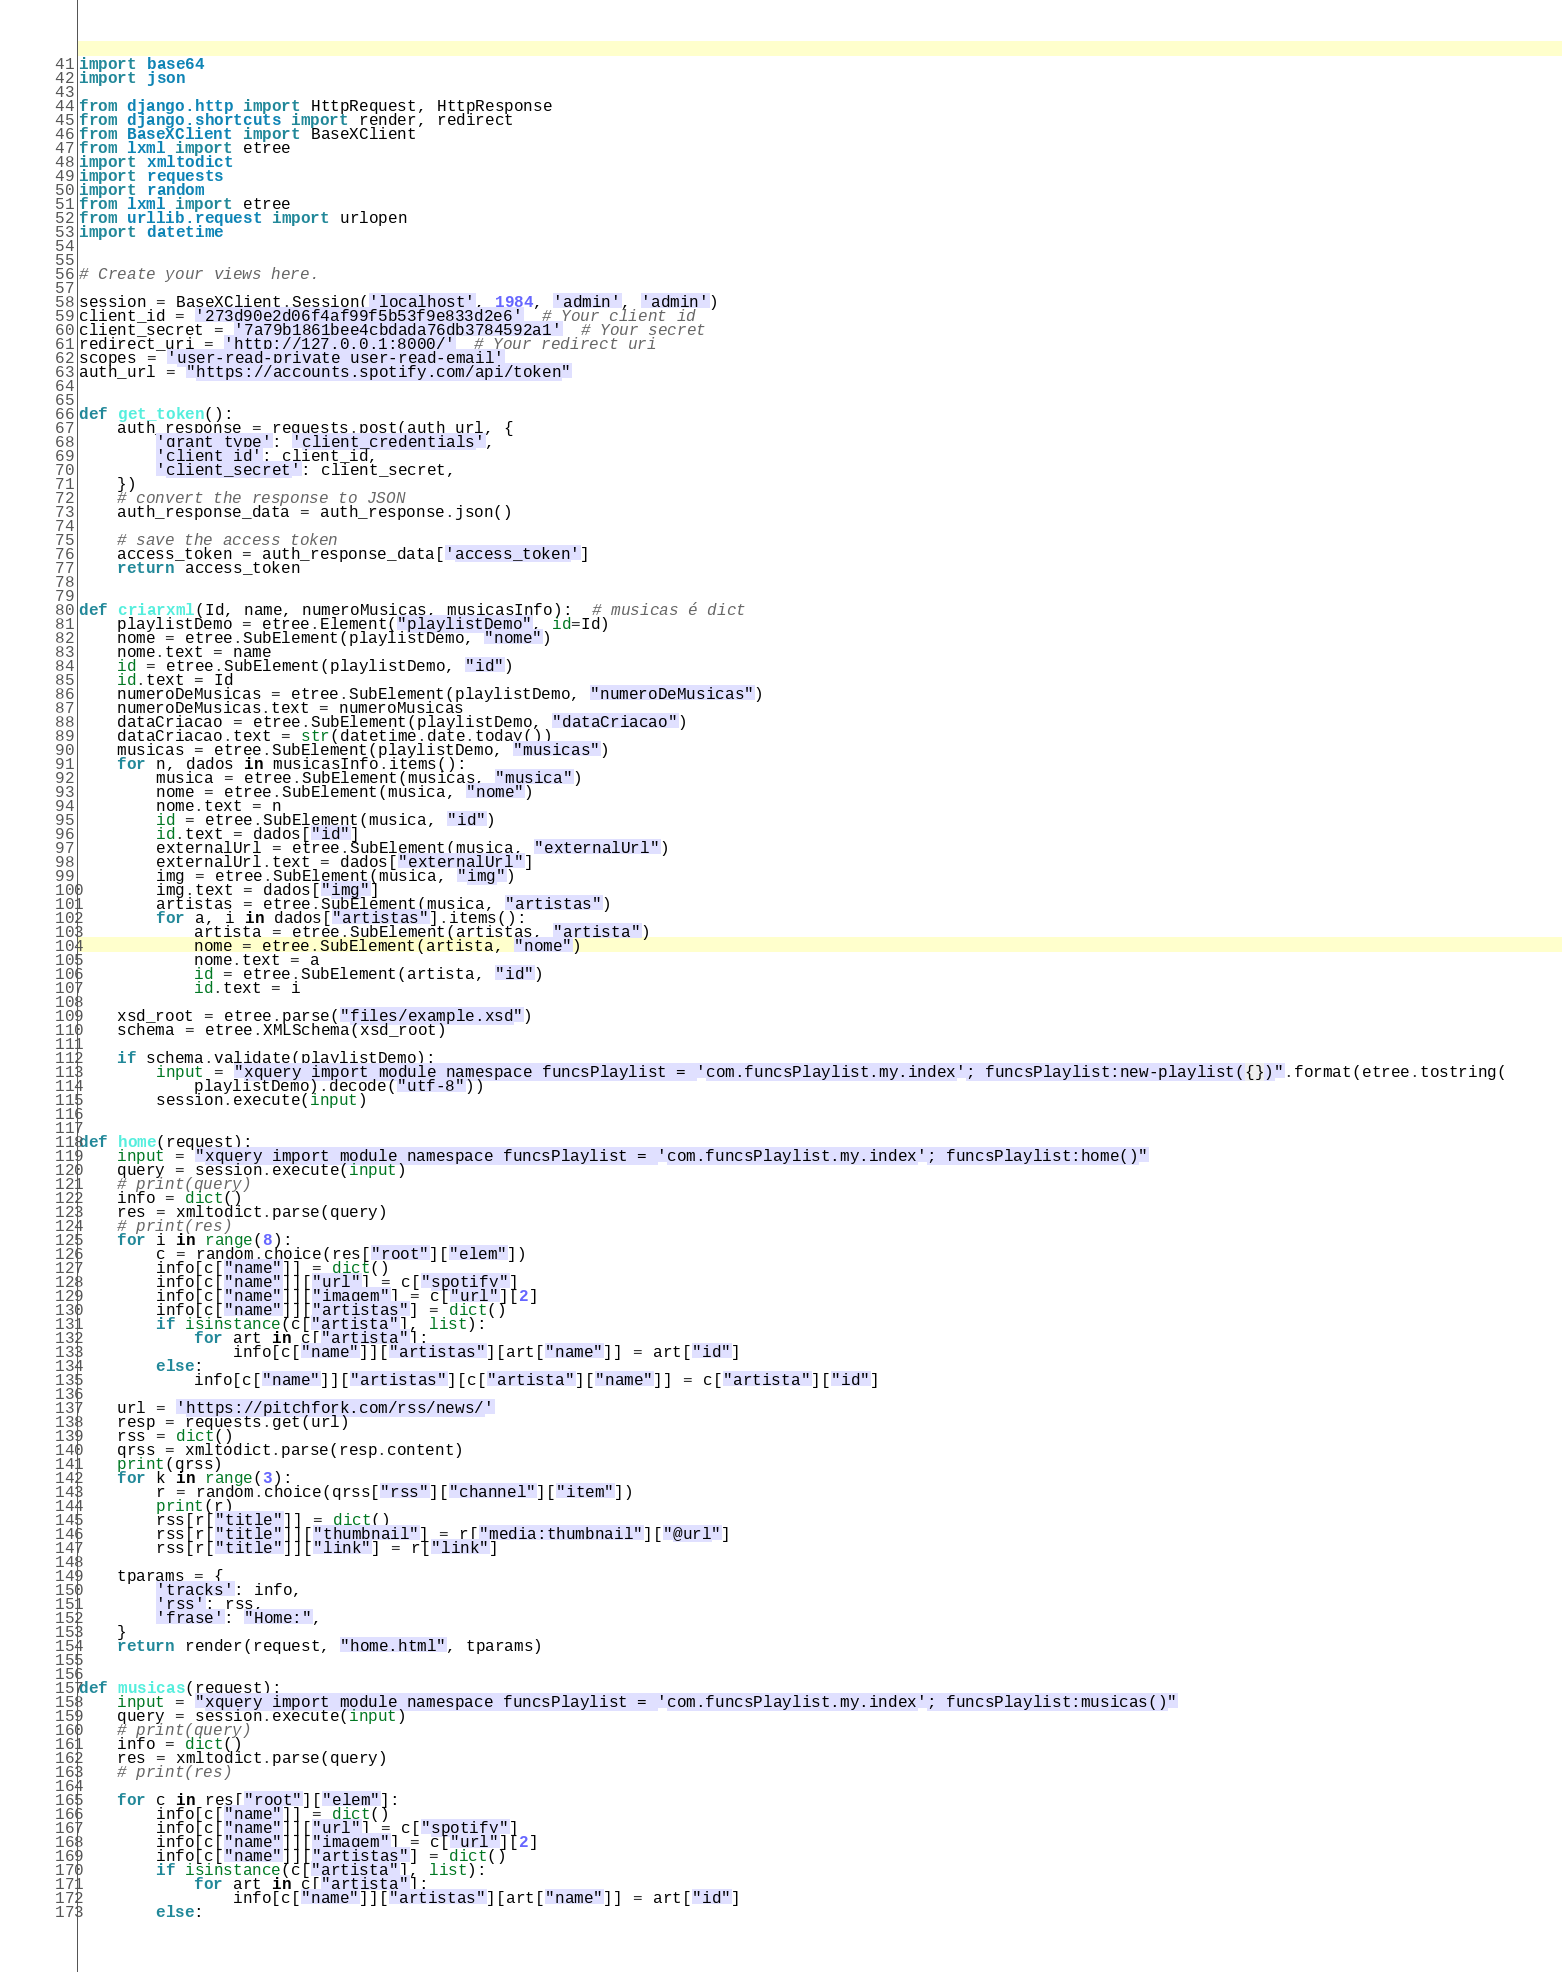Convert code to text. <code><loc_0><loc_0><loc_500><loc_500><_Python_>import base64
import json

from django.http import HttpRequest, HttpResponse
from django.shortcuts import render, redirect
from BaseXClient import BaseXClient
from lxml import etree
import xmltodict
import requests
import random
from lxml import etree
from urllib.request import urlopen
import datetime


# Create your views here.

session = BaseXClient.Session('localhost', 1984, 'admin', 'admin')
client_id = '273d90e2d06f4af99f5b53f9e833d2e6'  # Your client id
client_secret = '7a79b1861bee4cbdada76db3784592a1'  # Your secret
redirect_uri = 'http://127.0.0.1:8000/'  # Your redirect uri
scopes = 'user-read-private user-read-email'
auth_url = "https://accounts.spotify.com/api/token"


def get_token():
    auth_response = requests.post(auth_url, {
        'grant_type': 'client_credentials',
        'client_id': client_id,
        'client_secret': client_secret,
    })
    # convert the response to JSON
    auth_response_data = auth_response.json()

    # save the access token
    access_token = auth_response_data['access_token']
    return access_token


def criarxml(Id, name, numeroMusicas, musicasInfo):  # musicas é dict
    playlistDemo = etree.Element("playlistDemo", id=Id)
    nome = etree.SubElement(playlistDemo, "nome")
    nome.text = name
    id = etree.SubElement(playlistDemo, "id")
    id.text = Id
    numeroDeMusicas = etree.SubElement(playlistDemo, "numeroDeMusicas")
    numeroDeMusicas.text = numeroMusicas
    dataCriacao = etree.SubElement(playlistDemo, "dataCriacao")
    dataCriacao.text = str(datetime.date.today())
    musicas = etree.SubElement(playlistDemo, "musicas")
    for n, dados in musicasInfo.items():
        musica = etree.SubElement(musicas, "musica")
        nome = etree.SubElement(musica, "nome")
        nome.text = n
        id = etree.SubElement(musica, "id")
        id.text = dados["id"]
        externalUrl = etree.SubElement(musica, "externalUrl")
        externalUrl.text = dados["externalUrl"]
        img = etree.SubElement(musica, "img")
        img.text = dados["img"]
        artistas = etree.SubElement(musica, "artistas")
        for a, i in dados["artistas"].items():
            artista = etree.SubElement(artistas, "artista")
            nome = etree.SubElement(artista, "nome")
            nome.text = a
            id = etree.SubElement(artista, "id")
            id.text = i

    xsd_root = etree.parse("files/example.xsd")
    schema = etree.XMLSchema(xsd_root)

    if schema.validate(playlistDemo):
        input = "xquery import module namespace funcsPlaylist = 'com.funcsPlaylist.my.index'; funcsPlaylist:new-playlist({})".format(etree.tostring(
            playlistDemo).decode("utf-8"))
        session.execute(input)


def home(request):
    input = "xquery import module namespace funcsPlaylist = 'com.funcsPlaylist.my.index'; funcsPlaylist:home()"
    query = session.execute(input)
    # print(query)
    info = dict()
    res = xmltodict.parse(query)
    # print(res)
    for i in range(8):
        c = random.choice(res["root"]["elem"])
        info[c["name"]] = dict()
        info[c["name"]]["url"] = c["spotify"]
        info[c["name"]]["imagem"] = c["url"][2]
        info[c["name"]]["artistas"] = dict()
        if isinstance(c["artista"], list):
            for art in c["artista"]:
                info[c["name"]]["artistas"][art["name"]] = art["id"]
        else:
            info[c["name"]]["artistas"][c["artista"]["name"]] = c["artista"]["id"]

    url = 'https://pitchfork.com/rss/news/'
    resp = requests.get(url)
    rss = dict()
    qrss = xmltodict.parse(resp.content)
    print(qrss)
    for k in range(3):
        r = random.choice(qrss["rss"]["channel"]["item"])
        print(r)
        rss[r["title"]] = dict()
        rss[r["title"]]["thumbnail"] = r["media:thumbnail"]["@url"]
        rss[r["title"]]["link"] = r["link"]

    tparams = {
        'tracks': info,
        'rss': rss,
        'frase': "Home:",
    }
    return render(request, "home.html", tparams)


def musicas(request):
    input = "xquery import module namespace funcsPlaylist = 'com.funcsPlaylist.my.index'; funcsPlaylist:musicas()"
    query = session.execute(input)
    # print(query)
    info = dict()
    res = xmltodict.parse(query)
    # print(res)

    for c in res["root"]["elem"]:
        info[c["name"]] = dict()
        info[c["name"]]["url"] = c["spotify"]
        info[c["name"]]["imagem"] = c["url"][2]
        info[c["name"]]["artistas"] = dict()
        if isinstance(c["artista"], list):
            for art in c["artista"]:
                info[c["name"]]["artistas"][art["name"]] = art["id"]
        else:</code> 